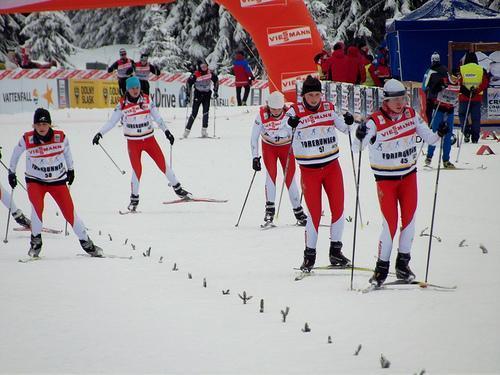How many teammates in red and white can you see?
Give a very brief answer. 5. 